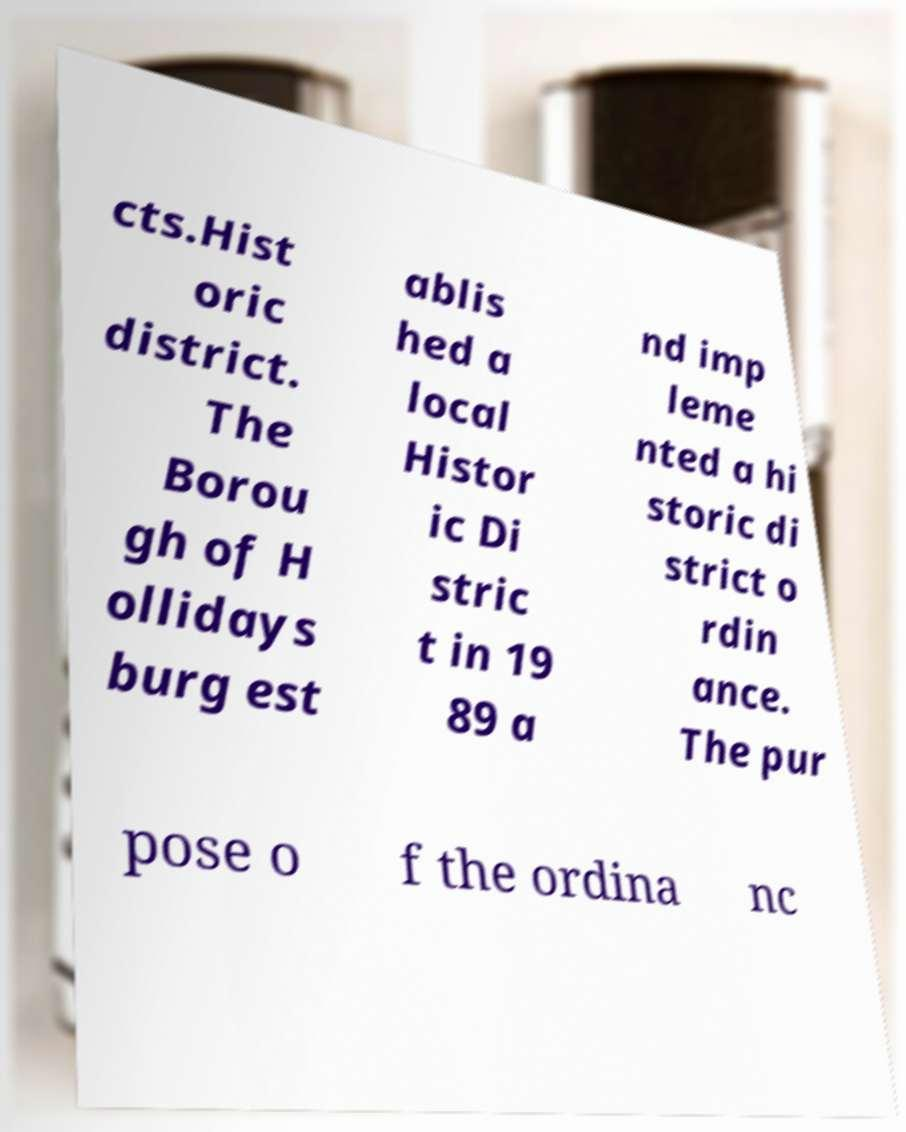Please read and relay the text visible in this image. What does it say? cts.Hist oric district. The Borou gh of H ollidays burg est ablis hed a local Histor ic Di stric t in 19 89 a nd imp leme nted a hi storic di strict o rdin ance. The pur pose o f the ordina nc 